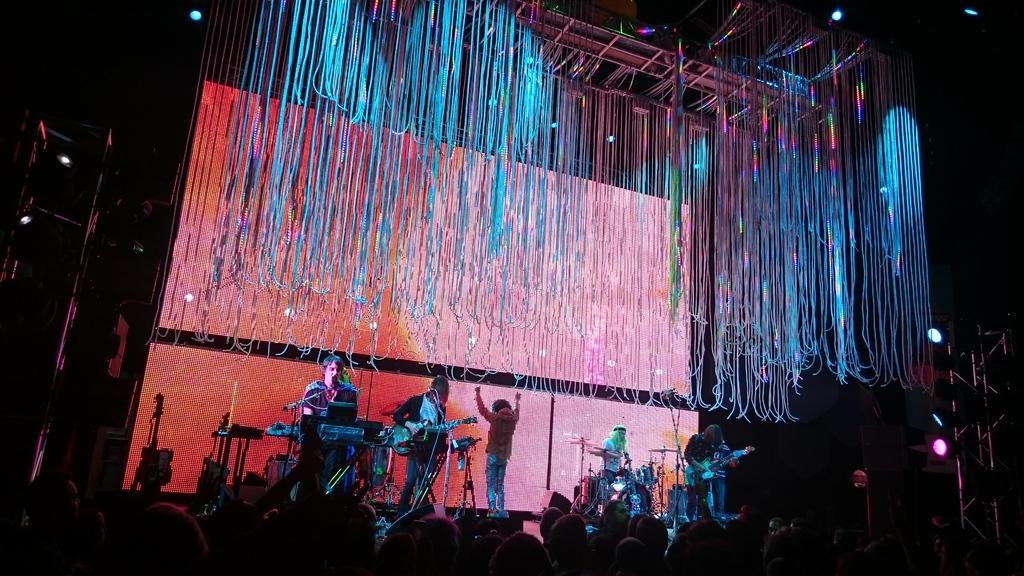Describe this image in one or two sentences. In this image we can see a group of people standing on the stage. In that some are holding the musical instruments. We can also see the miles with the stands, a board and some ribbons tied to a roof. We can also see some lights. On the bottom of the image we can see a group of people and the metal frame. 